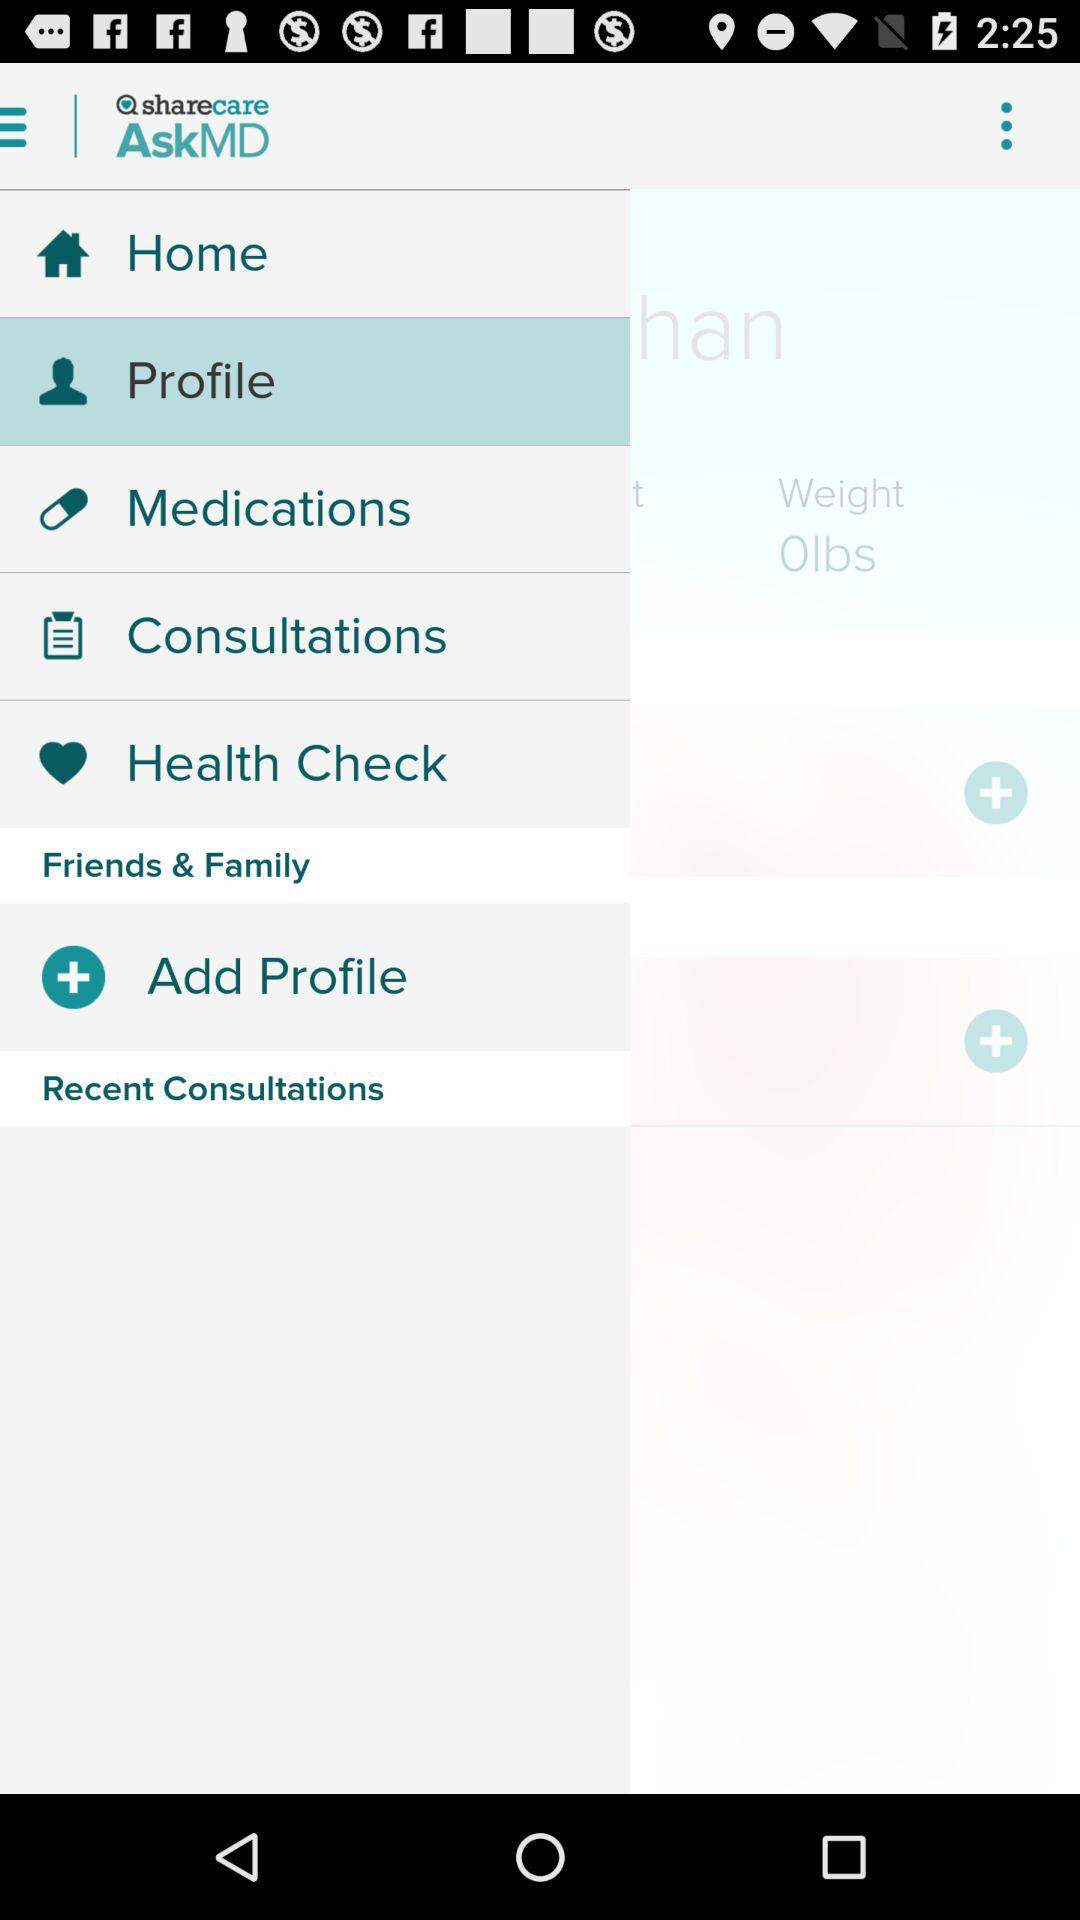What is the name of the application? The name of the application is "sharecare AskMD". 